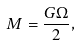<formula> <loc_0><loc_0><loc_500><loc_500>M = \frac { G \Omega } { 2 } ,</formula> 